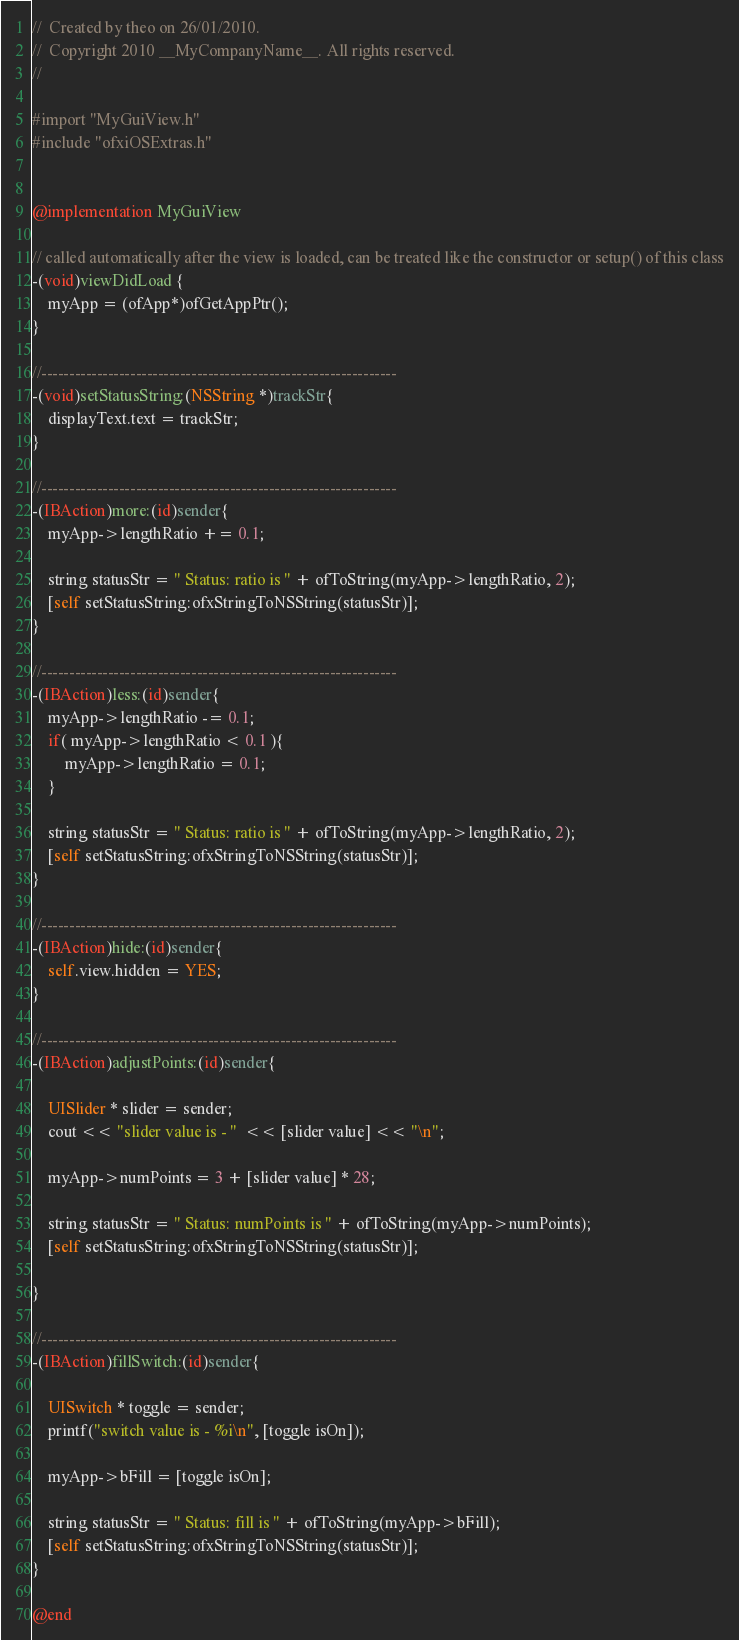Convert code to text. <code><loc_0><loc_0><loc_500><loc_500><_ObjectiveC_>//  Created by theo on 26/01/2010.
//  Copyright 2010 __MyCompanyName__. All rights reserved.
//

#import "MyGuiView.h"
#include "ofxiOSExtras.h"


@implementation MyGuiView

// called automatically after the view is loaded, can be treated like the constructor or setup() of this class
-(void)viewDidLoad {
	myApp = (ofApp*)ofGetAppPtr();
}

//----------------------------------------------------------------
-(void)setStatusString:(NSString *)trackStr{
	displayText.text = trackStr;
}

//----------------------------------------------------------------
-(IBAction)more:(id)sender{
	myApp->lengthRatio += 0.1;
	
	string statusStr = " Status: ratio is " + ofToString(myApp->lengthRatio, 2);
	[self setStatusString:ofxStringToNSString(statusStr)];		
}

//----------------------------------------------------------------
-(IBAction)less:(id)sender{
	myApp->lengthRatio -= 0.1;
	if( myApp->lengthRatio < 0.1 ){
		myApp->lengthRatio = 0.1;
	}

	string statusStr = " Status: ratio is " + ofToString(myApp->lengthRatio, 2);
	[self setStatusString:ofxStringToNSString(statusStr)];		
}

//----------------------------------------------------------------
-(IBAction)hide:(id)sender{
	self.view.hidden = YES;
}

//----------------------------------------------------------------
-(IBAction)adjustPoints:(id)sender{
	
	UISlider * slider = sender;
	cout << "slider value is - "  << [slider value] << "\n";
	
	myApp->numPoints = 3 + [slider value] * 28;
	
	string statusStr = " Status: numPoints is " + ofToString(myApp->numPoints);
	[self setStatusString:ofxStringToNSString(statusStr)];
	
}

//----------------------------------------------------------------
-(IBAction)fillSwitch:(id)sender{
	
	UISwitch * toggle = sender;
	printf("switch value is - %i\n", [toggle isOn]);
	
	myApp->bFill = [toggle isOn];
	
	string statusStr = " Status: fill is " + ofToString(myApp->bFill);
	[self setStatusString:ofxStringToNSString(statusStr)];	
}

@end
</code> 